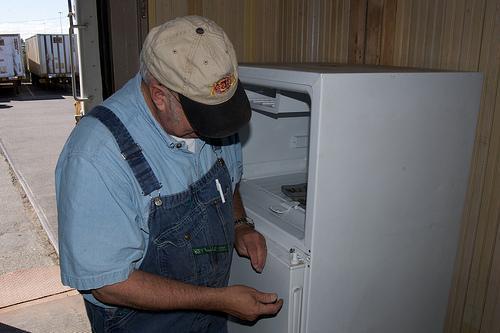How many people are there?
Give a very brief answer. 1. How many people are looking at the sky?
Give a very brief answer. 0. 